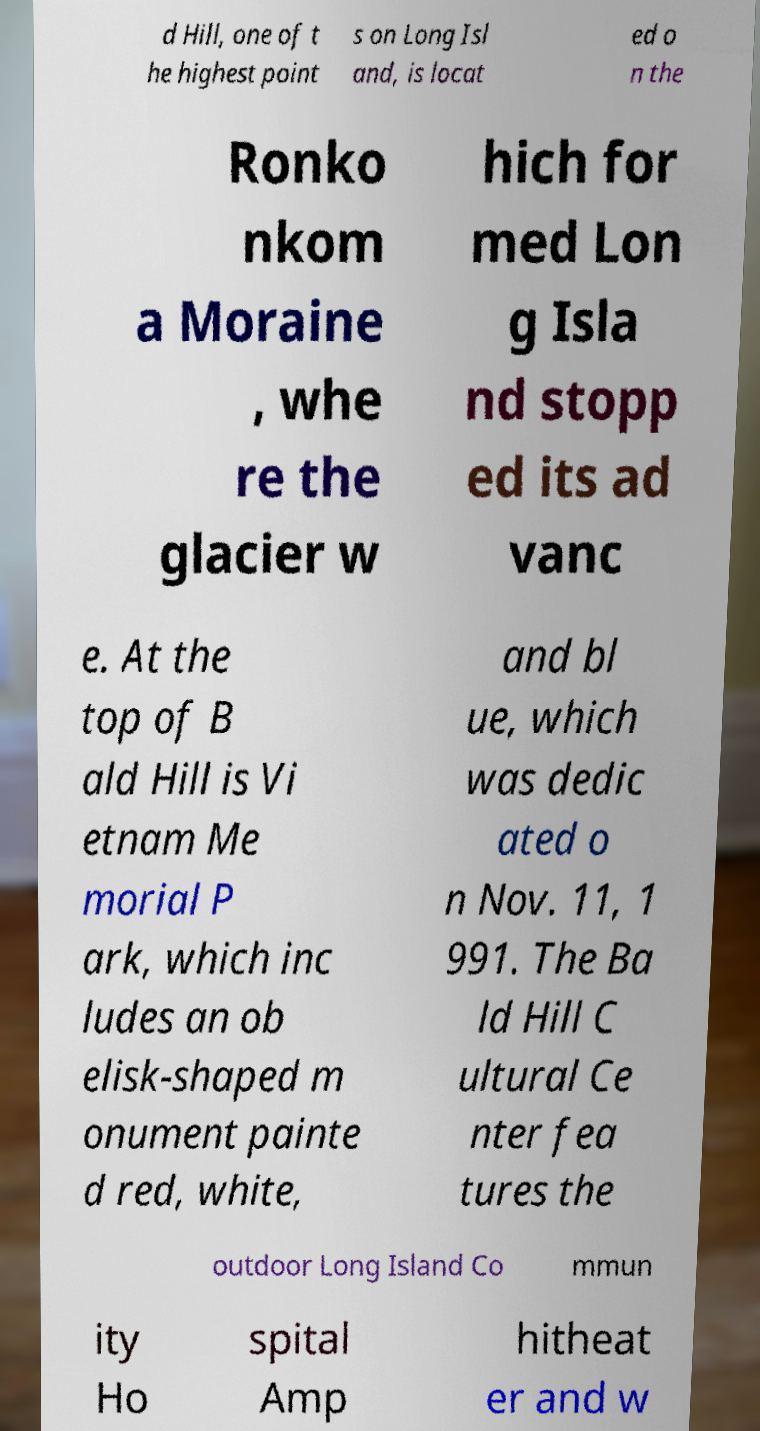What messages or text are displayed in this image? I need them in a readable, typed format. d Hill, one of t he highest point s on Long Isl and, is locat ed o n the Ronko nkom a Moraine , whe re the glacier w hich for med Lon g Isla nd stopp ed its ad vanc e. At the top of B ald Hill is Vi etnam Me morial P ark, which inc ludes an ob elisk-shaped m onument painte d red, white, and bl ue, which was dedic ated o n Nov. 11, 1 991. The Ba ld Hill C ultural Ce nter fea tures the outdoor Long Island Co mmun ity Ho spital Amp hitheat er and w 